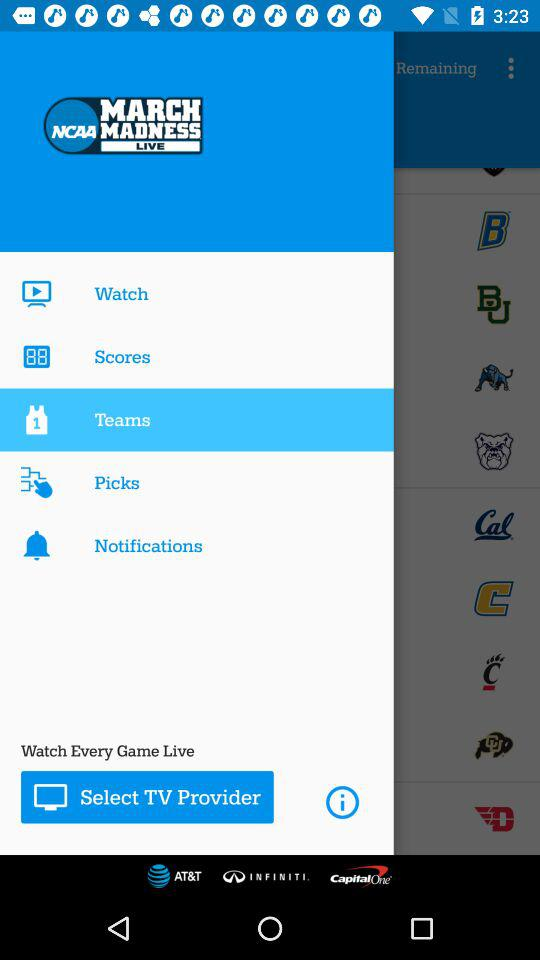How many notifications are there?
When the provided information is insufficient, respond with <no answer>. <no answer> 